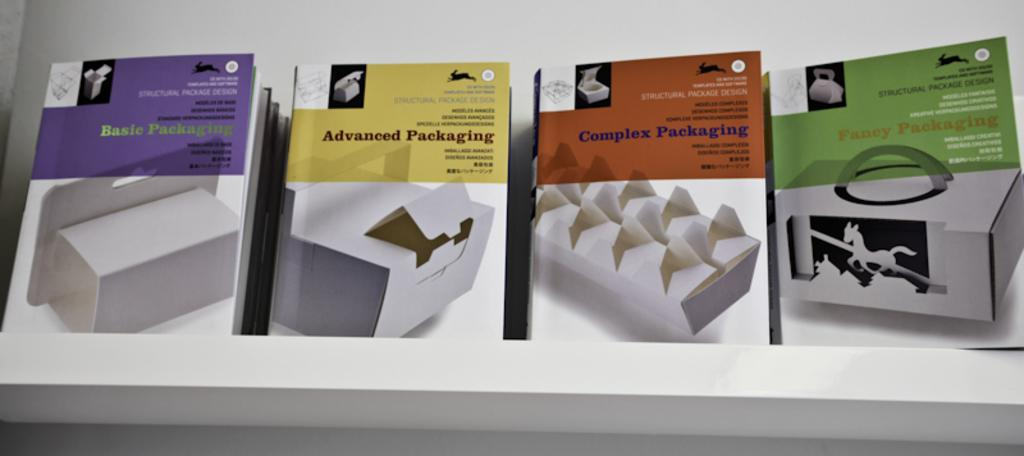<image>
Write a terse but informative summary of the picture. Basic through Fancy packaging are shown on these four example boxes. 